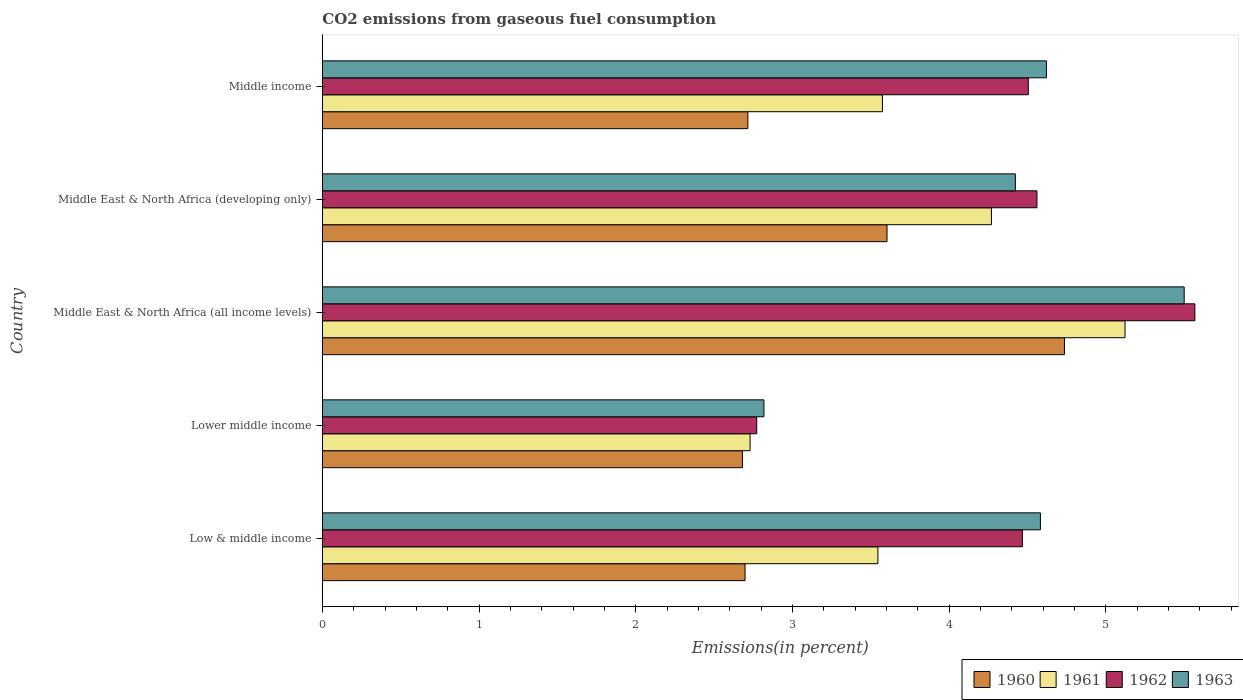How many different coloured bars are there?
Your response must be concise. 4. How many groups of bars are there?
Ensure brevity in your answer.  5. What is the label of the 1st group of bars from the top?
Ensure brevity in your answer.  Middle income. What is the total CO2 emitted in 1962 in Middle income?
Your answer should be compact. 4.5. Across all countries, what is the maximum total CO2 emitted in 1961?
Your response must be concise. 5.12. Across all countries, what is the minimum total CO2 emitted in 1961?
Make the answer very short. 2.73. In which country was the total CO2 emitted in 1963 maximum?
Provide a short and direct response. Middle East & North Africa (all income levels). In which country was the total CO2 emitted in 1962 minimum?
Ensure brevity in your answer.  Lower middle income. What is the total total CO2 emitted in 1962 in the graph?
Make the answer very short. 21.87. What is the difference between the total CO2 emitted in 1961 in Middle East & North Africa (all income levels) and that in Middle income?
Your answer should be very brief. 1.55. What is the difference between the total CO2 emitted in 1961 in Lower middle income and the total CO2 emitted in 1962 in Middle East & North Africa (developing only)?
Your answer should be very brief. -1.83. What is the average total CO2 emitted in 1961 per country?
Provide a short and direct response. 3.85. What is the difference between the total CO2 emitted in 1960 and total CO2 emitted in 1963 in Middle East & North Africa (all income levels)?
Your answer should be compact. -0.76. What is the ratio of the total CO2 emitted in 1962 in Low & middle income to that in Middle East & North Africa (all income levels)?
Offer a very short reply. 0.8. Is the difference between the total CO2 emitted in 1960 in Middle East & North Africa (all income levels) and Middle income greater than the difference between the total CO2 emitted in 1963 in Middle East & North Africa (all income levels) and Middle income?
Give a very brief answer. Yes. What is the difference between the highest and the second highest total CO2 emitted in 1960?
Your answer should be very brief. 1.13. What is the difference between the highest and the lowest total CO2 emitted in 1961?
Provide a short and direct response. 2.39. Is the sum of the total CO2 emitted in 1961 in Middle East & North Africa (developing only) and Middle income greater than the maximum total CO2 emitted in 1960 across all countries?
Offer a terse response. Yes. What does the 4th bar from the top in Middle East & North Africa (all income levels) represents?
Offer a terse response. 1960. What does the 2nd bar from the bottom in Middle East & North Africa (all income levels) represents?
Provide a short and direct response. 1961. How many countries are there in the graph?
Ensure brevity in your answer.  5. Are the values on the major ticks of X-axis written in scientific E-notation?
Your answer should be compact. No. Does the graph contain any zero values?
Make the answer very short. No. What is the title of the graph?
Keep it short and to the point. CO2 emissions from gaseous fuel consumption. Does "2006" appear as one of the legend labels in the graph?
Make the answer very short. No. What is the label or title of the X-axis?
Ensure brevity in your answer.  Emissions(in percent). What is the Emissions(in percent) in 1960 in Low & middle income?
Make the answer very short. 2.7. What is the Emissions(in percent) of 1961 in Low & middle income?
Ensure brevity in your answer.  3.55. What is the Emissions(in percent) of 1962 in Low & middle income?
Provide a succinct answer. 4.47. What is the Emissions(in percent) in 1963 in Low & middle income?
Your response must be concise. 4.58. What is the Emissions(in percent) in 1960 in Lower middle income?
Ensure brevity in your answer.  2.68. What is the Emissions(in percent) in 1961 in Lower middle income?
Offer a terse response. 2.73. What is the Emissions(in percent) in 1962 in Lower middle income?
Offer a very short reply. 2.77. What is the Emissions(in percent) of 1963 in Lower middle income?
Make the answer very short. 2.82. What is the Emissions(in percent) of 1960 in Middle East & North Africa (all income levels)?
Keep it short and to the point. 4.74. What is the Emissions(in percent) in 1961 in Middle East & North Africa (all income levels)?
Your answer should be very brief. 5.12. What is the Emissions(in percent) in 1962 in Middle East & North Africa (all income levels)?
Give a very brief answer. 5.57. What is the Emissions(in percent) of 1963 in Middle East & North Africa (all income levels)?
Provide a succinct answer. 5.5. What is the Emissions(in percent) of 1960 in Middle East & North Africa (developing only)?
Offer a very short reply. 3.6. What is the Emissions(in percent) in 1961 in Middle East & North Africa (developing only)?
Your response must be concise. 4.27. What is the Emissions(in percent) in 1962 in Middle East & North Africa (developing only)?
Offer a terse response. 4.56. What is the Emissions(in percent) in 1963 in Middle East & North Africa (developing only)?
Give a very brief answer. 4.42. What is the Emissions(in percent) in 1960 in Middle income?
Your answer should be compact. 2.72. What is the Emissions(in percent) of 1961 in Middle income?
Provide a succinct answer. 3.57. What is the Emissions(in percent) of 1962 in Middle income?
Your response must be concise. 4.5. What is the Emissions(in percent) of 1963 in Middle income?
Your answer should be compact. 4.62. Across all countries, what is the maximum Emissions(in percent) in 1960?
Ensure brevity in your answer.  4.74. Across all countries, what is the maximum Emissions(in percent) of 1961?
Offer a very short reply. 5.12. Across all countries, what is the maximum Emissions(in percent) of 1962?
Provide a short and direct response. 5.57. Across all countries, what is the maximum Emissions(in percent) of 1963?
Ensure brevity in your answer.  5.5. Across all countries, what is the minimum Emissions(in percent) of 1960?
Make the answer very short. 2.68. Across all countries, what is the minimum Emissions(in percent) in 1961?
Ensure brevity in your answer.  2.73. Across all countries, what is the minimum Emissions(in percent) of 1962?
Keep it short and to the point. 2.77. Across all countries, what is the minimum Emissions(in percent) of 1963?
Provide a succinct answer. 2.82. What is the total Emissions(in percent) of 1960 in the graph?
Your answer should be very brief. 16.43. What is the total Emissions(in percent) of 1961 in the graph?
Offer a very short reply. 19.24. What is the total Emissions(in percent) of 1962 in the graph?
Provide a short and direct response. 21.87. What is the total Emissions(in percent) in 1963 in the graph?
Give a very brief answer. 21.94. What is the difference between the Emissions(in percent) in 1960 in Low & middle income and that in Lower middle income?
Provide a succinct answer. 0.02. What is the difference between the Emissions(in percent) of 1961 in Low & middle income and that in Lower middle income?
Your answer should be very brief. 0.82. What is the difference between the Emissions(in percent) of 1962 in Low & middle income and that in Lower middle income?
Your response must be concise. 1.7. What is the difference between the Emissions(in percent) in 1963 in Low & middle income and that in Lower middle income?
Give a very brief answer. 1.76. What is the difference between the Emissions(in percent) of 1960 in Low & middle income and that in Middle East & North Africa (all income levels)?
Your answer should be very brief. -2.04. What is the difference between the Emissions(in percent) in 1961 in Low & middle income and that in Middle East & North Africa (all income levels)?
Keep it short and to the point. -1.58. What is the difference between the Emissions(in percent) of 1962 in Low & middle income and that in Middle East & North Africa (all income levels)?
Provide a succinct answer. -1.1. What is the difference between the Emissions(in percent) in 1963 in Low & middle income and that in Middle East & North Africa (all income levels)?
Provide a succinct answer. -0.92. What is the difference between the Emissions(in percent) in 1960 in Low & middle income and that in Middle East & North Africa (developing only)?
Give a very brief answer. -0.91. What is the difference between the Emissions(in percent) in 1961 in Low & middle income and that in Middle East & North Africa (developing only)?
Provide a short and direct response. -0.72. What is the difference between the Emissions(in percent) in 1962 in Low & middle income and that in Middle East & North Africa (developing only)?
Offer a terse response. -0.09. What is the difference between the Emissions(in percent) in 1963 in Low & middle income and that in Middle East & North Africa (developing only)?
Keep it short and to the point. 0.16. What is the difference between the Emissions(in percent) of 1960 in Low & middle income and that in Middle income?
Ensure brevity in your answer.  -0.02. What is the difference between the Emissions(in percent) in 1961 in Low & middle income and that in Middle income?
Provide a short and direct response. -0.03. What is the difference between the Emissions(in percent) in 1962 in Low & middle income and that in Middle income?
Offer a terse response. -0.04. What is the difference between the Emissions(in percent) in 1963 in Low & middle income and that in Middle income?
Your answer should be very brief. -0.04. What is the difference between the Emissions(in percent) in 1960 in Lower middle income and that in Middle East & North Africa (all income levels)?
Offer a very short reply. -2.06. What is the difference between the Emissions(in percent) of 1961 in Lower middle income and that in Middle East & North Africa (all income levels)?
Offer a terse response. -2.39. What is the difference between the Emissions(in percent) in 1962 in Lower middle income and that in Middle East & North Africa (all income levels)?
Make the answer very short. -2.8. What is the difference between the Emissions(in percent) of 1963 in Lower middle income and that in Middle East & North Africa (all income levels)?
Your answer should be very brief. -2.68. What is the difference between the Emissions(in percent) in 1960 in Lower middle income and that in Middle East & North Africa (developing only)?
Your answer should be compact. -0.92. What is the difference between the Emissions(in percent) of 1961 in Lower middle income and that in Middle East & North Africa (developing only)?
Keep it short and to the point. -1.54. What is the difference between the Emissions(in percent) of 1962 in Lower middle income and that in Middle East & North Africa (developing only)?
Provide a succinct answer. -1.79. What is the difference between the Emissions(in percent) in 1963 in Lower middle income and that in Middle East & North Africa (developing only)?
Keep it short and to the point. -1.6. What is the difference between the Emissions(in percent) in 1960 in Lower middle income and that in Middle income?
Keep it short and to the point. -0.03. What is the difference between the Emissions(in percent) in 1961 in Lower middle income and that in Middle income?
Your response must be concise. -0.84. What is the difference between the Emissions(in percent) in 1962 in Lower middle income and that in Middle income?
Provide a succinct answer. -1.73. What is the difference between the Emissions(in percent) of 1963 in Lower middle income and that in Middle income?
Provide a succinct answer. -1.8. What is the difference between the Emissions(in percent) in 1960 in Middle East & North Africa (all income levels) and that in Middle East & North Africa (developing only)?
Offer a terse response. 1.13. What is the difference between the Emissions(in percent) in 1961 in Middle East & North Africa (all income levels) and that in Middle East & North Africa (developing only)?
Keep it short and to the point. 0.85. What is the difference between the Emissions(in percent) in 1962 in Middle East & North Africa (all income levels) and that in Middle East & North Africa (developing only)?
Your response must be concise. 1.01. What is the difference between the Emissions(in percent) of 1963 in Middle East & North Africa (all income levels) and that in Middle East & North Africa (developing only)?
Provide a short and direct response. 1.08. What is the difference between the Emissions(in percent) of 1960 in Middle East & North Africa (all income levels) and that in Middle income?
Ensure brevity in your answer.  2.02. What is the difference between the Emissions(in percent) of 1961 in Middle East & North Africa (all income levels) and that in Middle income?
Your answer should be compact. 1.55. What is the difference between the Emissions(in percent) in 1962 in Middle East & North Africa (all income levels) and that in Middle income?
Your response must be concise. 1.06. What is the difference between the Emissions(in percent) in 1963 in Middle East & North Africa (all income levels) and that in Middle income?
Your response must be concise. 0.88. What is the difference between the Emissions(in percent) in 1960 in Middle East & North Africa (developing only) and that in Middle income?
Offer a very short reply. 0.89. What is the difference between the Emissions(in percent) in 1961 in Middle East & North Africa (developing only) and that in Middle income?
Provide a short and direct response. 0.7. What is the difference between the Emissions(in percent) of 1962 in Middle East & North Africa (developing only) and that in Middle income?
Give a very brief answer. 0.06. What is the difference between the Emissions(in percent) in 1963 in Middle East & North Africa (developing only) and that in Middle income?
Ensure brevity in your answer.  -0.2. What is the difference between the Emissions(in percent) in 1960 in Low & middle income and the Emissions(in percent) in 1961 in Lower middle income?
Your answer should be very brief. -0.03. What is the difference between the Emissions(in percent) of 1960 in Low & middle income and the Emissions(in percent) of 1962 in Lower middle income?
Offer a terse response. -0.07. What is the difference between the Emissions(in percent) in 1960 in Low & middle income and the Emissions(in percent) in 1963 in Lower middle income?
Your response must be concise. -0.12. What is the difference between the Emissions(in percent) of 1961 in Low & middle income and the Emissions(in percent) of 1962 in Lower middle income?
Ensure brevity in your answer.  0.77. What is the difference between the Emissions(in percent) of 1961 in Low & middle income and the Emissions(in percent) of 1963 in Lower middle income?
Offer a terse response. 0.73. What is the difference between the Emissions(in percent) of 1962 in Low & middle income and the Emissions(in percent) of 1963 in Lower middle income?
Provide a short and direct response. 1.65. What is the difference between the Emissions(in percent) in 1960 in Low & middle income and the Emissions(in percent) in 1961 in Middle East & North Africa (all income levels)?
Your response must be concise. -2.42. What is the difference between the Emissions(in percent) of 1960 in Low & middle income and the Emissions(in percent) of 1962 in Middle East & North Africa (all income levels)?
Keep it short and to the point. -2.87. What is the difference between the Emissions(in percent) of 1960 in Low & middle income and the Emissions(in percent) of 1963 in Middle East & North Africa (all income levels)?
Give a very brief answer. -2.8. What is the difference between the Emissions(in percent) in 1961 in Low & middle income and the Emissions(in percent) in 1962 in Middle East & North Africa (all income levels)?
Your answer should be very brief. -2.02. What is the difference between the Emissions(in percent) in 1961 in Low & middle income and the Emissions(in percent) in 1963 in Middle East & North Africa (all income levels)?
Keep it short and to the point. -1.95. What is the difference between the Emissions(in percent) in 1962 in Low & middle income and the Emissions(in percent) in 1963 in Middle East & North Africa (all income levels)?
Give a very brief answer. -1.03. What is the difference between the Emissions(in percent) in 1960 in Low & middle income and the Emissions(in percent) in 1961 in Middle East & North Africa (developing only)?
Make the answer very short. -1.57. What is the difference between the Emissions(in percent) in 1960 in Low & middle income and the Emissions(in percent) in 1962 in Middle East & North Africa (developing only)?
Give a very brief answer. -1.86. What is the difference between the Emissions(in percent) in 1960 in Low & middle income and the Emissions(in percent) in 1963 in Middle East & North Africa (developing only)?
Keep it short and to the point. -1.72. What is the difference between the Emissions(in percent) in 1961 in Low & middle income and the Emissions(in percent) in 1962 in Middle East & North Africa (developing only)?
Keep it short and to the point. -1.01. What is the difference between the Emissions(in percent) of 1961 in Low & middle income and the Emissions(in percent) of 1963 in Middle East & North Africa (developing only)?
Make the answer very short. -0.88. What is the difference between the Emissions(in percent) of 1962 in Low & middle income and the Emissions(in percent) of 1963 in Middle East & North Africa (developing only)?
Keep it short and to the point. 0.04. What is the difference between the Emissions(in percent) in 1960 in Low & middle income and the Emissions(in percent) in 1961 in Middle income?
Provide a succinct answer. -0.88. What is the difference between the Emissions(in percent) of 1960 in Low & middle income and the Emissions(in percent) of 1962 in Middle income?
Ensure brevity in your answer.  -1.81. What is the difference between the Emissions(in percent) in 1960 in Low & middle income and the Emissions(in percent) in 1963 in Middle income?
Your response must be concise. -1.92. What is the difference between the Emissions(in percent) of 1961 in Low & middle income and the Emissions(in percent) of 1962 in Middle income?
Provide a succinct answer. -0.96. What is the difference between the Emissions(in percent) of 1961 in Low & middle income and the Emissions(in percent) of 1963 in Middle income?
Make the answer very short. -1.08. What is the difference between the Emissions(in percent) of 1962 in Low & middle income and the Emissions(in percent) of 1963 in Middle income?
Make the answer very short. -0.15. What is the difference between the Emissions(in percent) of 1960 in Lower middle income and the Emissions(in percent) of 1961 in Middle East & North Africa (all income levels)?
Offer a terse response. -2.44. What is the difference between the Emissions(in percent) of 1960 in Lower middle income and the Emissions(in percent) of 1962 in Middle East & North Africa (all income levels)?
Keep it short and to the point. -2.89. What is the difference between the Emissions(in percent) of 1960 in Lower middle income and the Emissions(in percent) of 1963 in Middle East & North Africa (all income levels)?
Provide a short and direct response. -2.82. What is the difference between the Emissions(in percent) in 1961 in Lower middle income and the Emissions(in percent) in 1962 in Middle East & North Africa (all income levels)?
Ensure brevity in your answer.  -2.84. What is the difference between the Emissions(in percent) in 1961 in Lower middle income and the Emissions(in percent) in 1963 in Middle East & North Africa (all income levels)?
Give a very brief answer. -2.77. What is the difference between the Emissions(in percent) of 1962 in Lower middle income and the Emissions(in percent) of 1963 in Middle East & North Africa (all income levels)?
Give a very brief answer. -2.73. What is the difference between the Emissions(in percent) in 1960 in Lower middle income and the Emissions(in percent) in 1961 in Middle East & North Africa (developing only)?
Your answer should be compact. -1.59. What is the difference between the Emissions(in percent) in 1960 in Lower middle income and the Emissions(in percent) in 1962 in Middle East & North Africa (developing only)?
Ensure brevity in your answer.  -1.88. What is the difference between the Emissions(in percent) of 1960 in Lower middle income and the Emissions(in percent) of 1963 in Middle East & North Africa (developing only)?
Make the answer very short. -1.74. What is the difference between the Emissions(in percent) of 1961 in Lower middle income and the Emissions(in percent) of 1962 in Middle East & North Africa (developing only)?
Provide a succinct answer. -1.83. What is the difference between the Emissions(in percent) in 1961 in Lower middle income and the Emissions(in percent) in 1963 in Middle East & North Africa (developing only)?
Offer a terse response. -1.69. What is the difference between the Emissions(in percent) of 1962 in Lower middle income and the Emissions(in percent) of 1963 in Middle East & North Africa (developing only)?
Provide a succinct answer. -1.65. What is the difference between the Emissions(in percent) of 1960 in Lower middle income and the Emissions(in percent) of 1961 in Middle income?
Give a very brief answer. -0.89. What is the difference between the Emissions(in percent) in 1960 in Lower middle income and the Emissions(in percent) in 1962 in Middle income?
Ensure brevity in your answer.  -1.82. What is the difference between the Emissions(in percent) in 1960 in Lower middle income and the Emissions(in percent) in 1963 in Middle income?
Offer a very short reply. -1.94. What is the difference between the Emissions(in percent) of 1961 in Lower middle income and the Emissions(in percent) of 1962 in Middle income?
Provide a succinct answer. -1.78. What is the difference between the Emissions(in percent) of 1961 in Lower middle income and the Emissions(in percent) of 1963 in Middle income?
Keep it short and to the point. -1.89. What is the difference between the Emissions(in percent) of 1962 in Lower middle income and the Emissions(in percent) of 1963 in Middle income?
Offer a very short reply. -1.85. What is the difference between the Emissions(in percent) of 1960 in Middle East & North Africa (all income levels) and the Emissions(in percent) of 1961 in Middle East & North Africa (developing only)?
Make the answer very short. 0.47. What is the difference between the Emissions(in percent) of 1960 in Middle East & North Africa (all income levels) and the Emissions(in percent) of 1962 in Middle East & North Africa (developing only)?
Make the answer very short. 0.18. What is the difference between the Emissions(in percent) in 1960 in Middle East & North Africa (all income levels) and the Emissions(in percent) in 1963 in Middle East & North Africa (developing only)?
Make the answer very short. 0.31. What is the difference between the Emissions(in percent) of 1961 in Middle East & North Africa (all income levels) and the Emissions(in percent) of 1962 in Middle East & North Africa (developing only)?
Your answer should be compact. 0.56. What is the difference between the Emissions(in percent) in 1961 in Middle East & North Africa (all income levels) and the Emissions(in percent) in 1963 in Middle East & North Africa (developing only)?
Offer a very short reply. 0.7. What is the difference between the Emissions(in percent) in 1962 in Middle East & North Africa (all income levels) and the Emissions(in percent) in 1963 in Middle East & North Africa (developing only)?
Offer a very short reply. 1.15. What is the difference between the Emissions(in percent) of 1960 in Middle East & North Africa (all income levels) and the Emissions(in percent) of 1961 in Middle income?
Your answer should be compact. 1.16. What is the difference between the Emissions(in percent) of 1960 in Middle East & North Africa (all income levels) and the Emissions(in percent) of 1962 in Middle income?
Ensure brevity in your answer.  0.23. What is the difference between the Emissions(in percent) of 1960 in Middle East & North Africa (all income levels) and the Emissions(in percent) of 1963 in Middle income?
Provide a succinct answer. 0.12. What is the difference between the Emissions(in percent) of 1961 in Middle East & North Africa (all income levels) and the Emissions(in percent) of 1962 in Middle income?
Make the answer very short. 0.62. What is the difference between the Emissions(in percent) of 1961 in Middle East & North Africa (all income levels) and the Emissions(in percent) of 1963 in Middle income?
Offer a very short reply. 0.5. What is the difference between the Emissions(in percent) of 1962 in Middle East & North Africa (all income levels) and the Emissions(in percent) of 1963 in Middle income?
Make the answer very short. 0.95. What is the difference between the Emissions(in percent) in 1960 in Middle East & North Africa (developing only) and the Emissions(in percent) in 1961 in Middle income?
Ensure brevity in your answer.  0.03. What is the difference between the Emissions(in percent) in 1960 in Middle East & North Africa (developing only) and the Emissions(in percent) in 1962 in Middle income?
Offer a very short reply. -0.9. What is the difference between the Emissions(in percent) in 1960 in Middle East & North Africa (developing only) and the Emissions(in percent) in 1963 in Middle income?
Make the answer very short. -1.02. What is the difference between the Emissions(in percent) of 1961 in Middle East & North Africa (developing only) and the Emissions(in percent) of 1962 in Middle income?
Your response must be concise. -0.24. What is the difference between the Emissions(in percent) of 1961 in Middle East & North Africa (developing only) and the Emissions(in percent) of 1963 in Middle income?
Make the answer very short. -0.35. What is the difference between the Emissions(in percent) of 1962 in Middle East & North Africa (developing only) and the Emissions(in percent) of 1963 in Middle income?
Your response must be concise. -0.06. What is the average Emissions(in percent) of 1960 per country?
Your response must be concise. 3.29. What is the average Emissions(in percent) of 1961 per country?
Offer a terse response. 3.85. What is the average Emissions(in percent) of 1962 per country?
Provide a short and direct response. 4.37. What is the average Emissions(in percent) in 1963 per country?
Provide a succinct answer. 4.39. What is the difference between the Emissions(in percent) of 1960 and Emissions(in percent) of 1961 in Low & middle income?
Your response must be concise. -0.85. What is the difference between the Emissions(in percent) of 1960 and Emissions(in percent) of 1962 in Low & middle income?
Your answer should be compact. -1.77. What is the difference between the Emissions(in percent) of 1960 and Emissions(in percent) of 1963 in Low & middle income?
Your answer should be very brief. -1.88. What is the difference between the Emissions(in percent) of 1961 and Emissions(in percent) of 1962 in Low & middle income?
Ensure brevity in your answer.  -0.92. What is the difference between the Emissions(in percent) in 1961 and Emissions(in percent) in 1963 in Low & middle income?
Give a very brief answer. -1.04. What is the difference between the Emissions(in percent) in 1962 and Emissions(in percent) in 1963 in Low & middle income?
Provide a short and direct response. -0.12. What is the difference between the Emissions(in percent) in 1960 and Emissions(in percent) in 1961 in Lower middle income?
Ensure brevity in your answer.  -0.05. What is the difference between the Emissions(in percent) of 1960 and Emissions(in percent) of 1962 in Lower middle income?
Keep it short and to the point. -0.09. What is the difference between the Emissions(in percent) of 1960 and Emissions(in percent) of 1963 in Lower middle income?
Your answer should be very brief. -0.14. What is the difference between the Emissions(in percent) of 1961 and Emissions(in percent) of 1962 in Lower middle income?
Your response must be concise. -0.04. What is the difference between the Emissions(in percent) in 1961 and Emissions(in percent) in 1963 in Lower middle income?
Make the answer very short. -0.09. What is the difference between the Emissions(in percent) in 1962 and Emissions(in percent) in 1963 in Lower middle income?
Your answer should be compact. -0.05. What is the difference between the Emissions(in percent) of 1960 and Emissions(in percent) of 1961 in Middle East & North Africa (all income levels)?
Ensure brevity in your answer.  -0.39. What is the difference between the Emissions(in percent) of 1960 and Emissions(in percent) of 1962 in Middle East & North Africa (all income levels)?
Make the answer very short. -0.83. What is the difference between the Emissions(in percent) of 1960 and Emissions(in percent) of 1963 in Middle East & North Africa (all income levels)?
Offer a terse response. -0.76. What is the difference between the Emissions(in percent) in 1961 and Emissions(in percent) in 1962 in Middle East & North Africa (all income levels)?
Offer a very short reply. -0.45. What is the difference between the Emissions(in percent) in 1961 and Emissions(in percent) in 1963 in Middle East & North Africa (all income levels)?
Make the answer very short. -0.38. What is the difference between the Emissions(in percent) of 1962 and Emissions(in percent) of 1963 in Middle East & North Africa (all income levels)?
Offer a terse response. 0.07. What is the difference between the Emissions(in percent) in 1960 and Emissions(in percent) in 1961 in Middle East & North Africa (developing only)?
Provide a short and direct response. -0.67. What is the difference between the Emissions(in percent) of 1960 and Emissions(in percent) of 1962 in Middle East & North Africa (developing only)?
Give a very brief answer. -0.96. What is the difference between the Emissions(in percent) in 1960 and Emissions(in percent) in 1963 in Middle East & North Africa (developing only)?
Offer a very short reply. -0.82. What is the difference between the Emissions(in percent) in 1961 and Emissions(in percent) in 1962 in Middle East & North Africa (developing only)?
Your response must be concise. -0.29. What is the difference between the Emissions(in percent) of 1961 and Emissions(in percent) of 1963 in Middle East & North Africa (developing only)?
Ensure brevity in your answer.  -0.15. What is the difference between the Emissions(in percent) of 1962 and Emissions(in percent) of 1963 in Middle East & North Africa (developing only)?
Your answer should be compact. 0.14. What is the difference between the Emissions(in percent) in 1960 and Emissions(in percent) in 1961 in Middle income?
Offer a very short reply. -0.86. What is the difference between the Emissions(in percent) of 1960 and Emissions(in percent) of 1962 in Middle income?
Give a very brief answer. -1.79. What is the difference between the Emissions(in percent) in 1960 and Emissions(in percent) in 1963 in Middle income?
Keep it short and to the point. -1.91. What is the difference between the Emissions(in percent) of 1961 and Emissions(in percent) of 1962 in Middle income?
Your response must be concise. -0.93. What is the difference between the Emissions(in percent) of 1961 and Emissions(in percent) of 1963 in Middle income?
Provide a short and direct response. -1.05. What is the difference between the Emissions(in percent) in 1962 and Emissions(in percent) in 1963 in Middle income?
Keep it short and to the point. -0.12. What is the ratio of the Emissions(in percent) of 1960 in Low & middle income to that in Lower middle income?
Offer a very short reply. 1.01. What is the ratio of the Emissions(in percent) of 1961 in Low & middle income to that in Lower middle income?
Offer a terse response. 1.3. What is the ratio of the Emissions(in percent) of 1962 in Low & middle income to that in Lower middle income?
Give a very brief answer. 1.61. What is the ratio of the Emissions(in percent) of 1963 in Low & middle income to that in Lower middle income?
Give a very brief answer. 1.63. What is the ratio of the Emissions(in percent) in 1960 in Low & middle income to that in Middle East & North Africa (all income levels)?
Your answer should be compact. 0.57. What is the ratio of the Emissions(in percent) in 1961 in Low & middle income to that in Middle East & North Africa (all income levels)?
Your answer should be compact. 0.69. What is the ratio of the Emissions(in percent) in 1962 in Low & middle income to that in Middle East & North Africa (all income levels)?
Make the answer very short. 0.8. What is the ratio of the Emissions(in percent) of 1963 in Low & middle income to that in Middle East & North Africa (all income levels)?
Your response must be concise. 0.83. What is the ratio of the Emissions(in percent) of 1960 in Low & middle income to that in Middle East & North Africa (developing only)?
Ensure brevity in your answer.  0.75. What is the ratio of the Emissions(in percent) in 1961 in Low & middle income to that in Middle East & North Africa (developing only)?
Offer a terse response. 0.83. What is the ratio of the Emissions(in percent) of 1962 in Low & middle income to that in Middle East & North Africa (developing only)?
Make the answer very short. 0.98. What is the ratio of the Emissions(in percent) in 1963 in Low & middle income to that in Middle East & North Africa (developing only)?
Provide a succinct answer. 1.04. What is the ratio of the Emissions(in percent) of 1960 in Low & middle income to that in Middle income?
Give a very brief answer. 0.99. What is the ratio of the Emissions(in percent) in 1960 in Lower middle income to that in Middle East & North Africa (all income levels)?
Your answer should be very brief. 0.57. What is the ratio of the Emissions(in percent) in 1961 in Lower middle income to that in Middle East & North Africa (all income levels)?
Your response must be concise. 0.53. What is the ratio of the Emissions(in percent) of 1962 in Lower middle income to that in Middle East & North Africa (all income levels)?
Make the answer very short. 0.5. What is the ratio of the Emissions(in percent) in 1963 in Lower middle income to that in Middle East & North Africa (all income levels)?
Make the answer very short. 0.51. What is the ratio of the Emissions(in percent) of 1960 in Lower middle income to that in Middle East & North Africa (developing only)?
Offer a very short reply. 0.74. What is the ratio of the Emissions(in percent) in 1961 in Lower middle income to that in Middle East & North Africa (developing only)?
Offer a very short reply. 0.64. What is the ratio of the Emissions(in percent) in 1962 in Lower middle income to that in Middle East & North Africa (developing only)?
Offer a terse response. 0.61. What is the ratio of the Emissions(in percent) of 1963 in Lower middle income to that in Middle East & North Africa (developing only)?
Offer a terse response. 0.64. What is the ratio of the Emissions(in percent) of 1960 in Lower middle income to that in Middle income?
Ensure brevity in your answer.  0.99. What is the ratio of the Emissions(in percent) in 1961 in Lower middle income to that in Middle income?
Provide a short and direct response. 0.76. What is the ratio of the Emissions(in percent) in 1962 in Lower middle income to that in Middle income?
Provide a succinct answer. 0.62. What is the ratio of the Emissions(in percent) of 1963 in Lower middle income to that in Middle income?
Ensure brevity in your answer.  0.61. What is the ratio of the Emissions(in percent) of 1960 in Middle East & North Africa (all income levels) to that in Middle East & North Africa (developing only)?
Your answer should be very brief. 1.31. What is the ratio of the Emissions(in percent) of 1961 in Middle East & North Africa (all income levels) to that in Middle East & North Africa (developing only)?
Your response must be concise. 1.2. What is the ratio of the Emissions(in percent) in 1962 in Middle East & North Africa (all income levels) to that in Middle East & North Africa (developing only)?
Ensure brevity in your answer.  1.22. What is the ratio of the Emissions(in percent) in 1963 in Middle East & North Africa (all income levels) to that in Middle East & North Africa (developing only)?
Keep it short and to the point. 1.24. What is the ratio of the Emissions(in percent) of 1960 in Middle East & North Africa (all income levels) to that in Middle income?
Provide a short and direct response. 1.74. What is the ratio of the Emissions(in percent) in 1961 in Middle East & North Africa (all income levels) to that in Middle income?
Keep it short and to the point. 1.43. What is the ratio of the Emissions(in percent) of 1962 in Middle East & North Africa (all income levels) to that in Middle income?
Your response must be concise. 1.24. What is the ratio of the Emissions(in percent) in 1963 in Middle East & North Africa (all income levels) to that in Middle income?
Ensure brevity in your answer.  1.19. What is the ratio of the Emissions(in percent) of 1960 in Middle East & North Africa (developing only) to that in Middle income?
Offer a very short reply. 1.33. What is the ratio of the Emissions(in percent) in 1961 in Middle East & North Africa (developing only) to that in Middle income?
Keep it short and to the point. 1.19. What is the ratio of the Emissions(in percent) in 1962 in Middle East & North Africa (developing only) to that in Middle income?
Provide a short and direct response. 1.01. What is the ratio of the Emissions(in percent) in 1963 in Middle East & North Africa (developing only) to that in Middle income?
Your answer should be very brief. 0.96. What is the difference between the highest and the second highest Emissions(in percent) in 1960?
Offer a very short reply. 1.13. What is the difference between the highest and the second highest Emissions(in percent) in 1961?
Offer a very short reply. 0.85. What is the difference between the highest and the second highest Emissions(in percent) in 1962?
Keep it short and to the point. 1.01. What is the difference between the highest and the second highest Emissions(in percent) of 1963?
Give a very brief answer. 0.88. What is the difference between the highest and the lowest Emissions(in percent) of 1960?
Your answer should be compact. 2.06. What is the difference between the highest and the lowest Emissions(in percent) of 1961?
Your response must be concise. 2.39. What is the difference between the highest and the lowest Emissions(in percent) in 1962?
Keep it short and to the point. 2.8. What is the difference between the highest and the lowest Emissions(in percent) in 1963?
Your response must be concise. 2.68. 